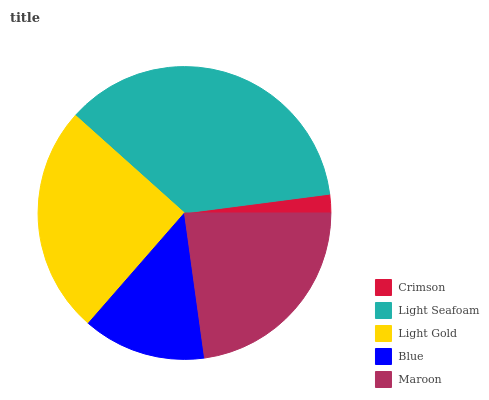Is Crimson the minimum?
Answer yes or no. Yes. Is Light Seafoam the maximum?
Answer yes or no. Yes. Is Light Gold the minimum?
Answer yes or no. No. Is Light Gold the maximum?
Answer yes or no. No. Is Light Seafoam greater than Light Gold?
Answer yes or no. Yes. Is Light Gold less than Light Seafoam?
Answer yes or no. Yes. Is Light Gold greater than Light Seafoam?
Answer yes or no. No. Is Light Seafoam less than Light Gold?
Answer yes or no. No. Is Maroon the high median?
Answer yes or no. Yes. Is Maroon the low median?
Answer yes or no. Yes. Is Light Seafoam the high median?
Answer yes or no. No. Is Crimson the low median?
Answer yes or no. No. 